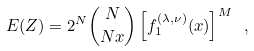Convert formula to latex. <formula><loc_0><loc_0><loc_500><loc_500>E ( Z ) = 2 ^ { N } \binom { N } { N x } \left [ f _ { 1 } ^ { ( \lambda , \nu ) } ( x ) \right ] ^ { M } \ ,</formula> 